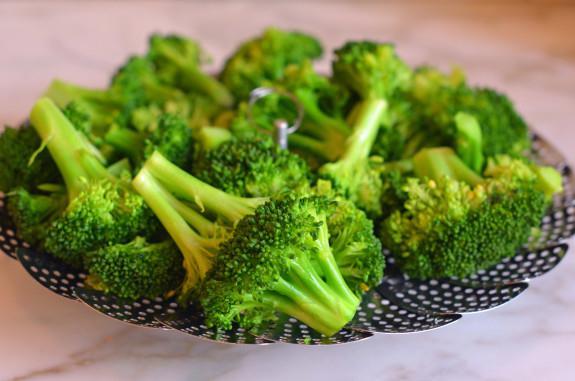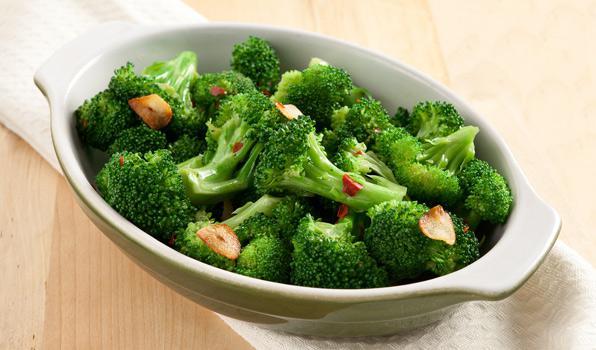The first image is the image on the left, the second image is the image on the right. Assess this claim about the two images: "The left and right image contains the same number of porcelain plates holding broccoli.". Correct or not? Answer yes or no. No. 